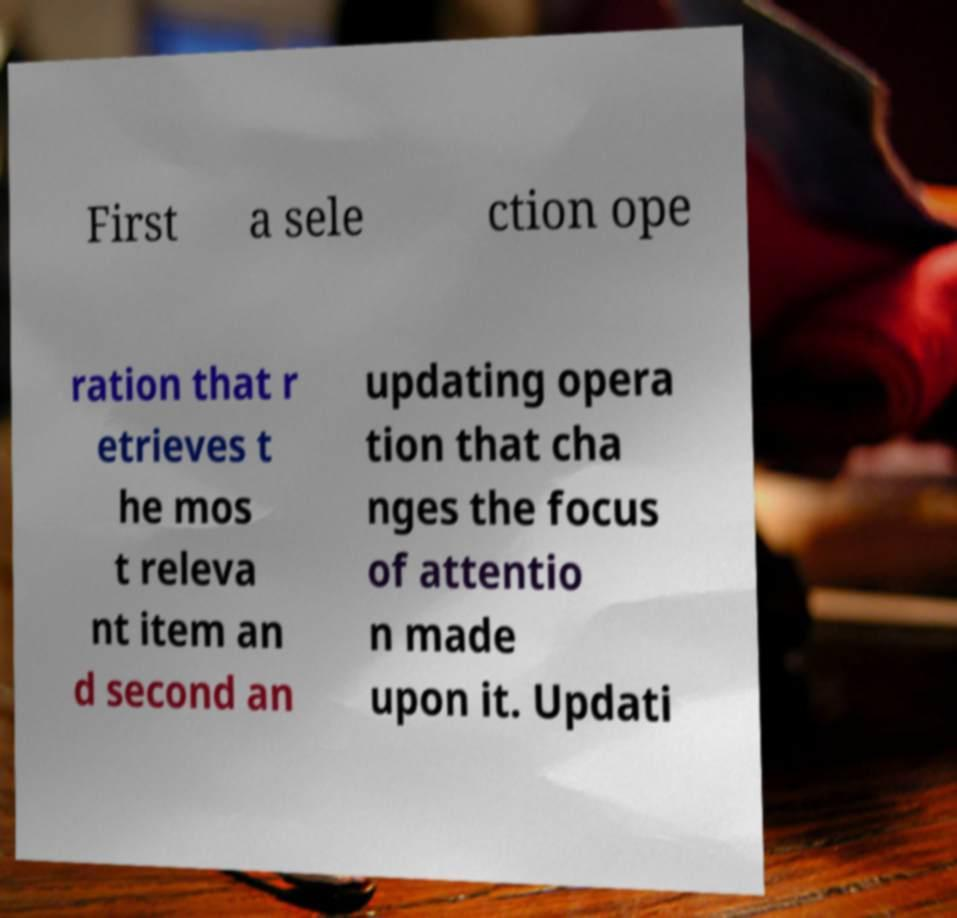Could you extract and type out the text from this image? First a sele ction ope ration that r etrieves t he mos t releva nt item an d second an updating opera tion that cha nges the focus of attentio n made upon it. Updati 